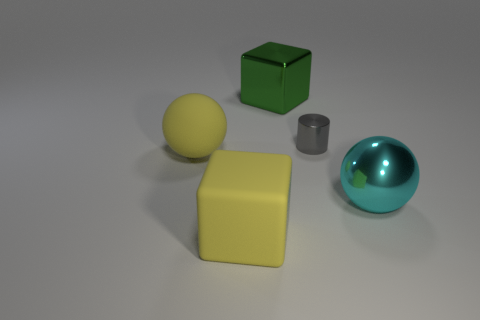Add 1 green metallic cubes. How many objects exist? 6 Subtract all cubes. How many objects are left? 3 Subtract 0 blue spheres. How many objects are left? 5 Subtract all tiny shiny objects. Subtract all big metallic spheres. How many objects are left? 3 Add 4 green metal cubes. How many green metal cubes are left? 5 Add 2 blue metal cubes. How many blue metal cubes exist? 2 